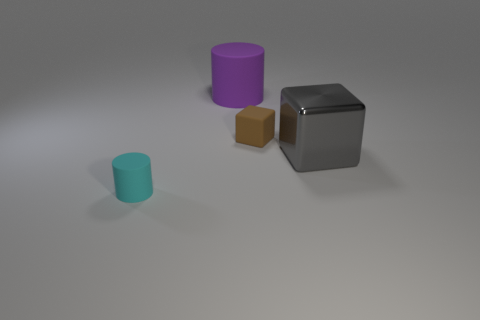Add 2 gray things. How many objects exist? 6 Subtract all large gray balls. Subtract all rubber cylinders. How many objects are left? 2 Add 3 large gray cubes. How many large gray cubes are left? 4 Add 4 tiny cylinders. How many tiny cylinders exist? 5 Subtract 1 brown blocks. How many objects are left? 3 